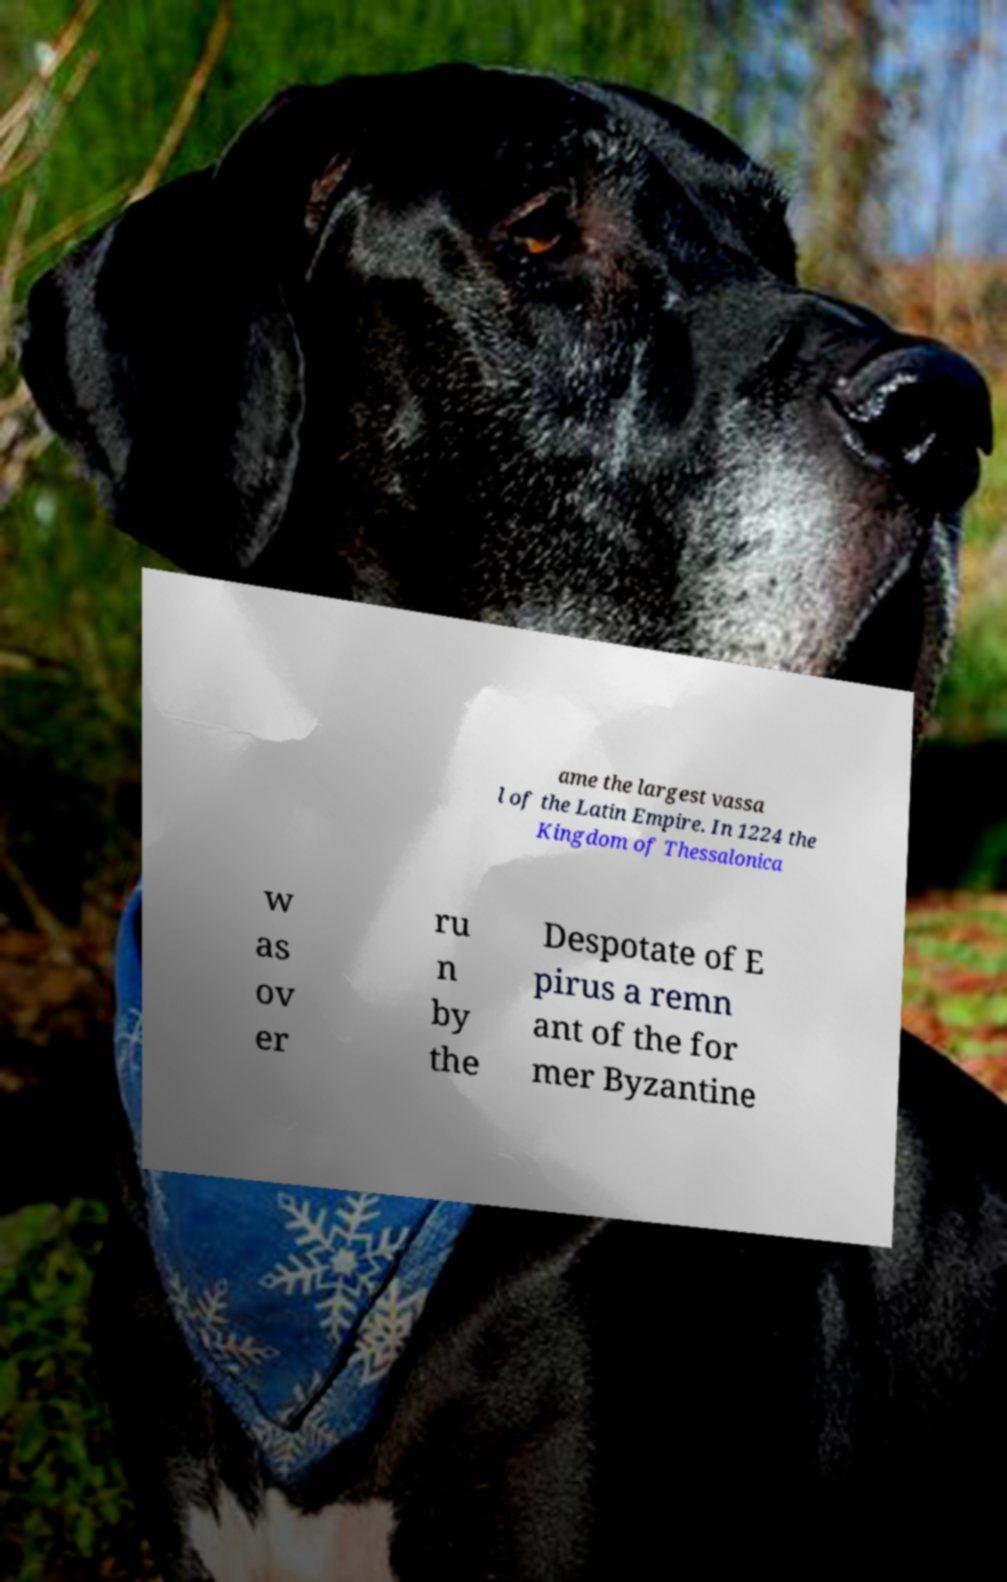Can you read and provide the text displayed in the image?This photo seems to have some interesting text. Can you extract and type it out for me? ame the largest vassa l of the Latin Empire. In 1224 the Kingdom of Thessalonica w as ov er ru n by the Despotate of E pirus a remn ant of the for mer Byzantine 